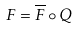Convert formula to latex. <formula><loc_0><loc_0><loc_500><loc_500>F = \overline { F } \circ Q</formula> 